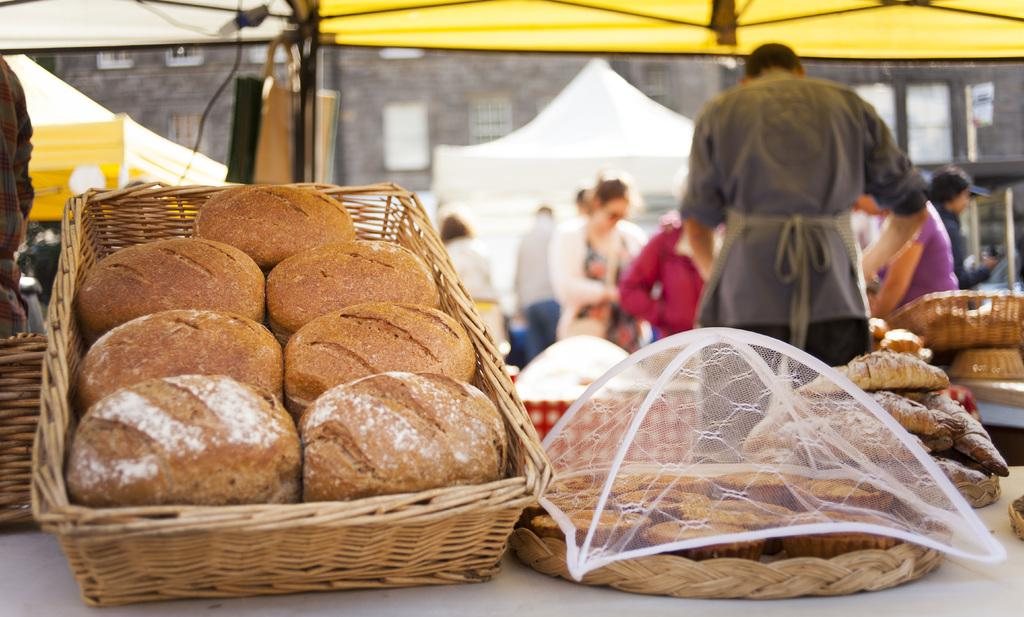What is contained in the baskets that are visible in the image? There are baskets with food in the image. Where are the baskets located? The baskets are on a platform. What is used to cover the baskets? There is a net lid in the image. Can you describe the people in the background of the image? There are people standing in the background of the image. What type of mine is visible in the image? There is no mine present in the image. How many cracks can be seen on the unit in the image? There is no unit present in the image, so it is not possible to determine the number of cracks. 